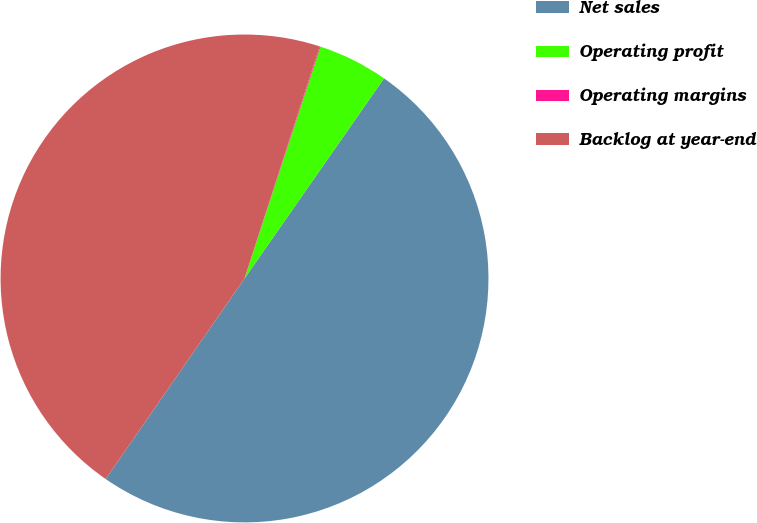Convert chart. <chart><loc_0><loc_0><loc_500><loc_500><pie_chart><fcel>Net sales<fcel>Operating profit<fcel>Operating margins<fcel>Backlog at year-end<nl><fcel>49.95%<fcel>4.65%<fcel>0.05%<fcel>45.35%<nl></chart> 